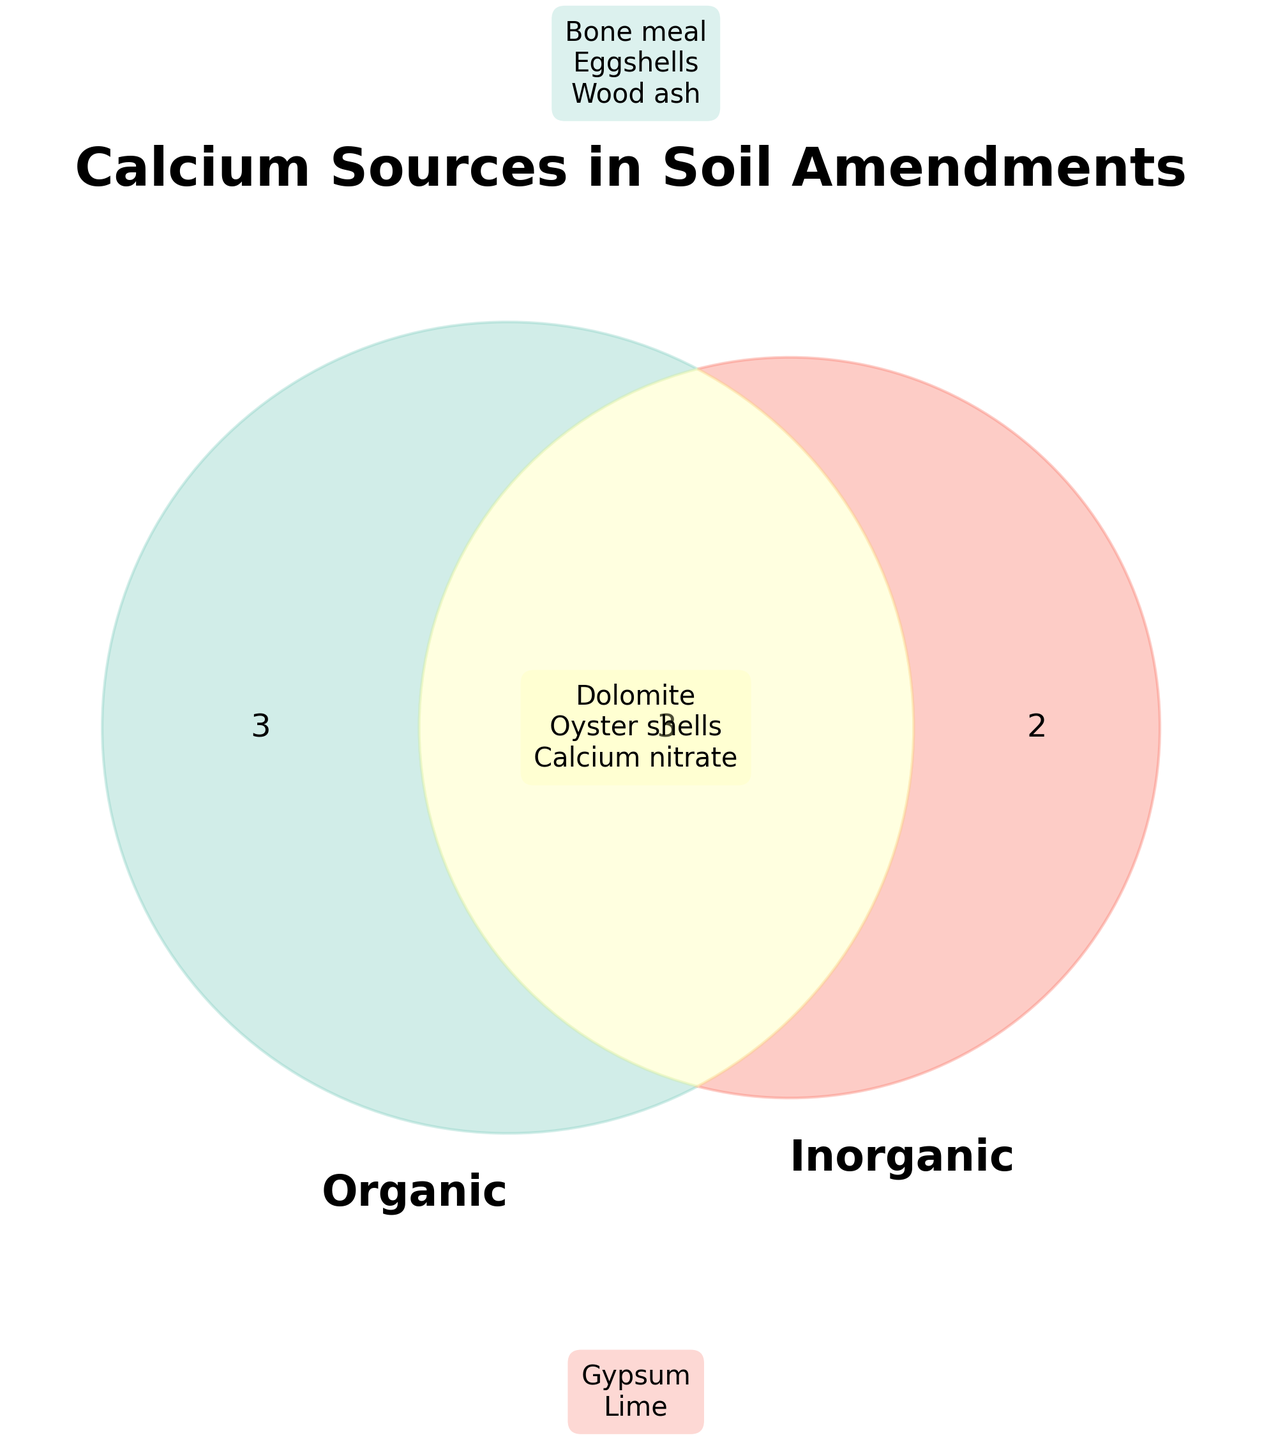What is the title of the figure? The title of the figure is written at the top and reads "Calcium Sources in Soil Amendments".
Answer: Calcium Sources in Soil Amendments Which items are purely organic? The items in the section labeled "Organic" in the Venn diagram are purely organic. These items are Bone meal, Eggshells, and Wood ash.
Answer: Bone meal, Eggshells, Wood ash Which items are in the overlapping region of the Venn diagram? The overlapping region of the Venn diagram shows items that are both organic and inorganic. These items are Dolomite, Oyster shells, and Calcium nitrate.
Answer: Dolomite, Oyster shells, Calcium nitrate How many items are purely inorganic? To determine the number of purely inorganic items, count the items in the section labeled "Inorganic". These items are Gypsum and Lime, totaling two items.
Answer: 2 Which category has more items, strictly organic or strictly inorganic? Count the items in each category: Organic has three items (Bone meal, Eggshells, Wood ash) while Inorganic has two items (Gypsum, Lime). Organic has more items.
Answer: Organic What are the colors used to represent the purely organic and purely inorganic items? The color for purely organic items is a light green (patch 10), and the color for purely inorganic items is a light red-orange (patch 01).
Answer: Light green, Light red-orange Are there more items that are both organic and inorganic or purely inorganic? There are three items in the overlapping region (Dolomite, Oyster shells, Calcium nitrate) and two items in the purely inorganic section (Gypsum, Lime). Therefore, there are more items that are both organic and inorganic.
Answer: Both organic and inorganic Which items are closer in the list, Bone meal or Lime? Bone meal and Lime belong to different categories. Bone meal is in Organic, which is listed near the top, while Lime is in Inorganic, listed at the bottom. Bone meal is closer in the list.
Answer: Bone meal 